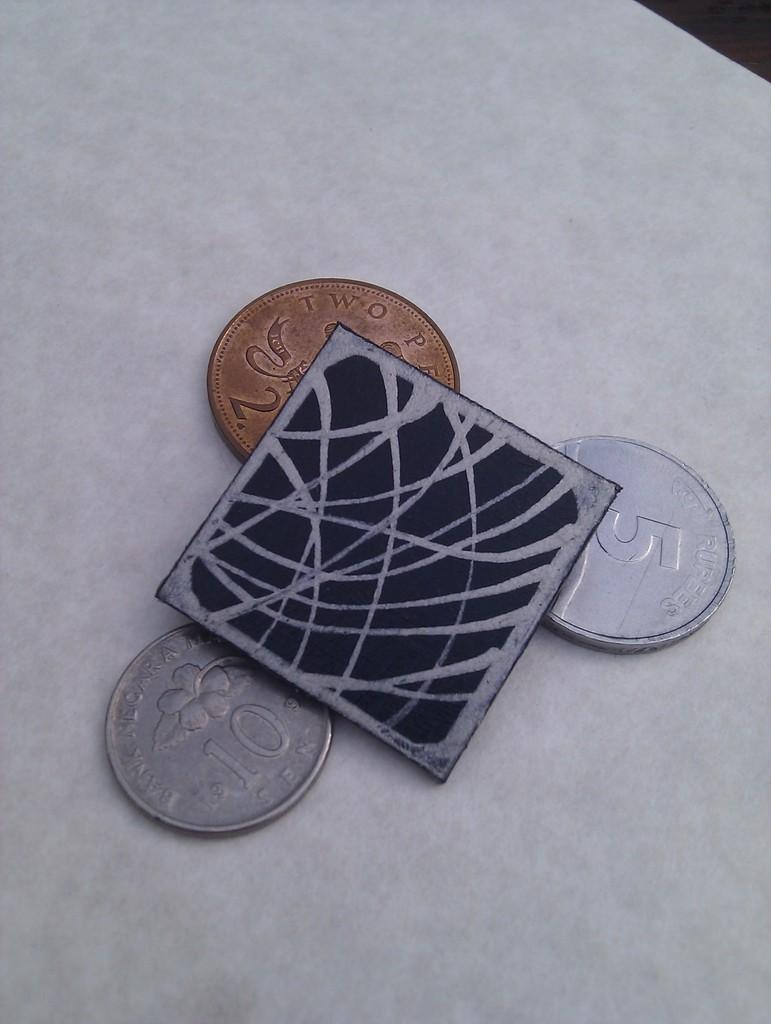<image>
Write a terse but informative summary of the picture. three coins, 5, 10, and 2 are under a black card 